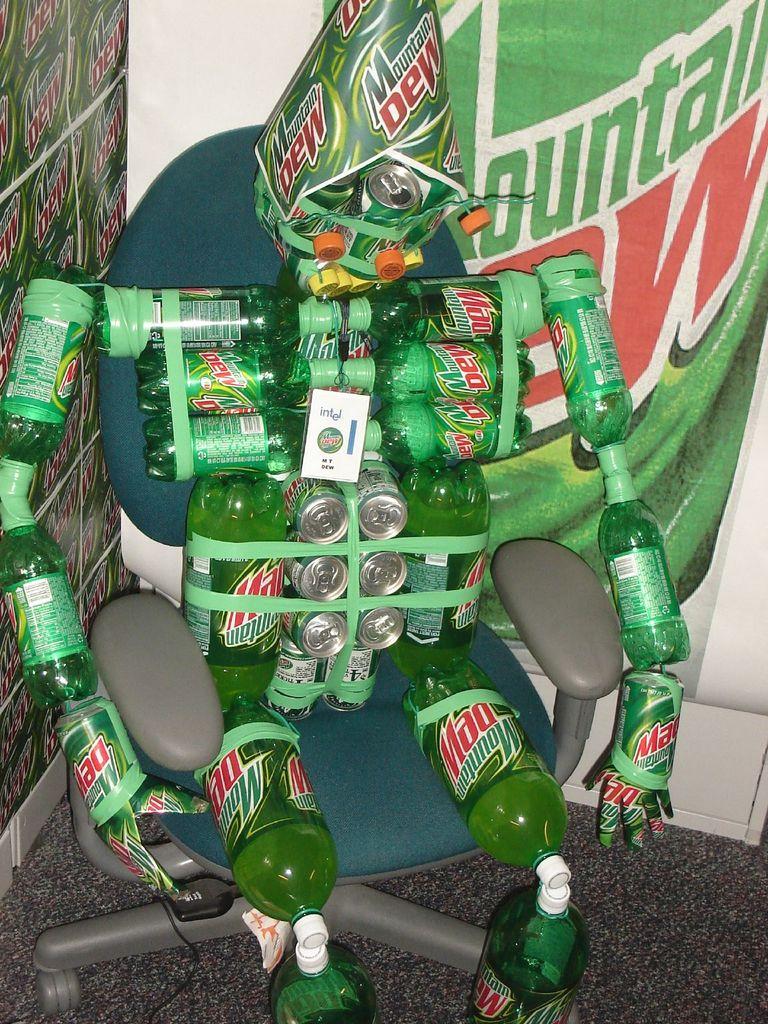What kind of soda was used to build this statue?
Offer a terse response. Mountain dew. What word in red is repeated in this photo?
Make the answer very short. Dew. 